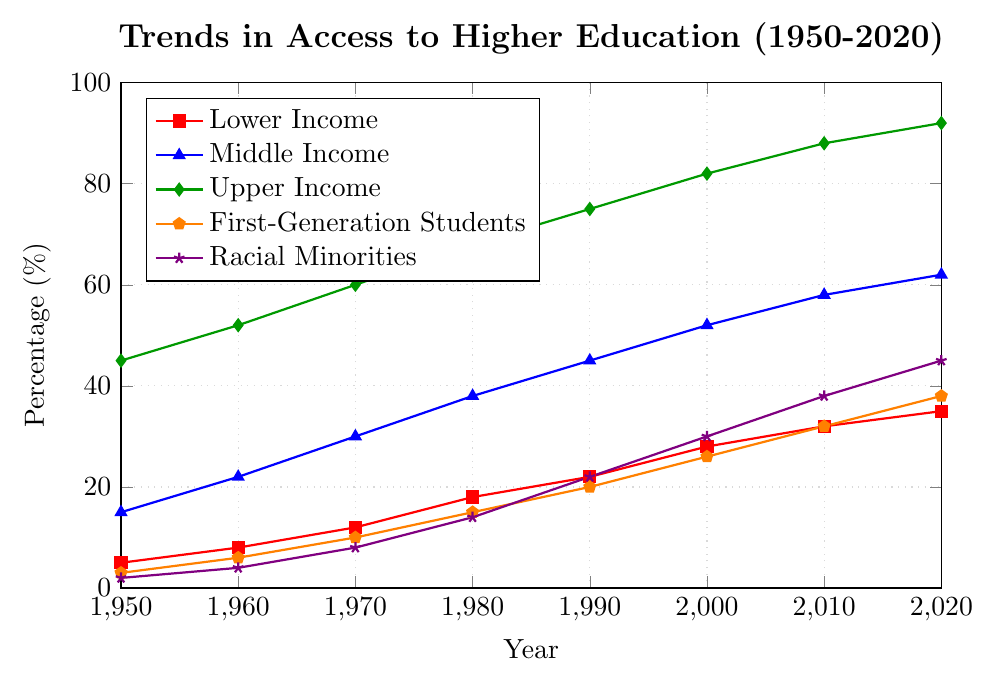In which year did the Lower Income group have the largest percentage increase in access compared to the previous decade? To find this, calculate the increases for each decade: (1960-1950)=3, (1970-1960)=4, (1980-1970)=6, (1990-1980)=4, (2000-1990)=6, (2010-2000)=4, (2020-2010)=3. The largest increase is 6 between 1970-1980 and 1990-2000.
Answer: 1980 or 2000 Which income group saw the smallest increase in percentage access from 1950 to 2020? Calculate the increase for each group from 1950 to 2020: Lower Income=(35-5)=30, Middle Income=(62-15)=47, Upper Income=(92-45)=47. The Lower Income group had the smallest increase of 30%.
Answer: Lower Income Compare the percentage of First-Generation Students and Racial Minorities in 1990. Which group had higher access and by how much? The percentages are First-Generation Students=20% and Racial Minorities=22%. Racial Minorities had 2% higher access.
Answer: Racial Minorities by 2% What is the average percentage of Upper Income access across all decades represented? The percentages are (45+52+60+68+75+82+88+92)/8=70.25%.
Answer: 70.25% What is the combined percentage of access for Lower Income and Middle Income groups in 2010? Add the percentages for both groups in 2010: 32% + 58% = 90%.
Answer: 90% Which group had a greater rate of increase in access from 1960 to 2000, First-Generation Students or Racial Minorities? For First-Generation Students, the increase is (26-6)=20. For Racial Minorities, the increase is (30-4)=26. Racial Minorities had a greater increase.
Answer: Racial Minorities Between which two consecutive decades did the Middle Income group experience the highest percentage increase in access? Calculate the increases for each decade: (1960-1950)=7, (1970-1960)=8, (1980-1970)=8, (1990-1980)=7, (2000-1990)=7, (2010-2000)=6, (2020-2010)=4. The highest increase is 8 between 1960-1970 and 1970-1980.
Answer: 1960-1980 What is the difference in access percentages between Middle Income and Lower Income groups in 2020? The percentages are Middle Income=62% and Lower Income=35%, with a difference of 62-35=27%.
Answer: 27% How does the access percentage for Racial Minorities in 2020 compare to the Upper Income group in 1960? The percentages are Racial Minorities=45% and Upper Income=52%. 45% is 7% less than 52%.
Answer: 7% less What are the two groups that had the same percentage increase in access from 1950 to 1980? Calculate increases for each group: Lower Income=(18-5)=13, Middle Income=(38-15)=23, Upper Income=(68-45)=23, First-Generation Students=(15-3)=12, Racial Minorities=(14-2)=12. Middle Income and Upper Income both had an increase of 23%.
Answer: Middle Income and Upper Income 